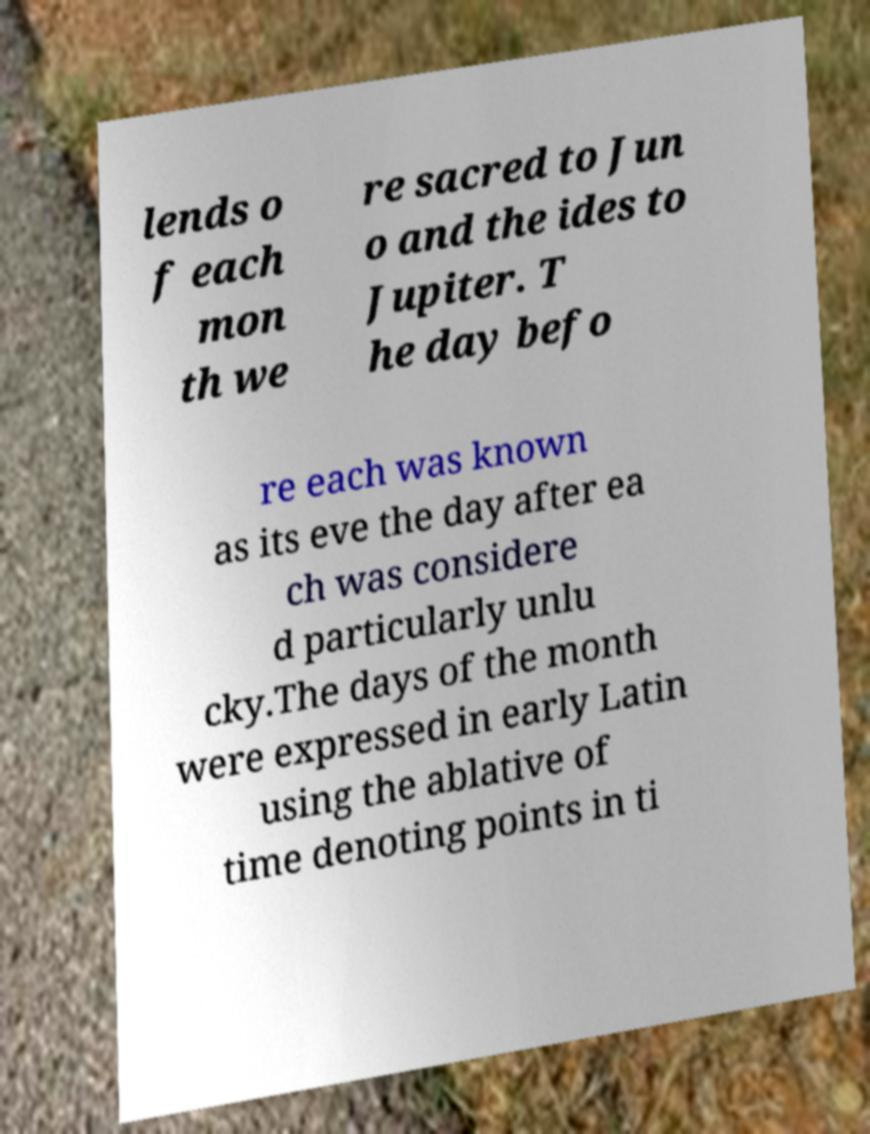Please identify and transcribe the text found in this image. lends o f each mon th we re sacred to Jun o and the ides to Jupiter. T he day befo re each was known as its eve the day after ea ch was considere d particularly unlu cky.The days of the month were expressed in early Latin using the ablative of time denoting points in ti 